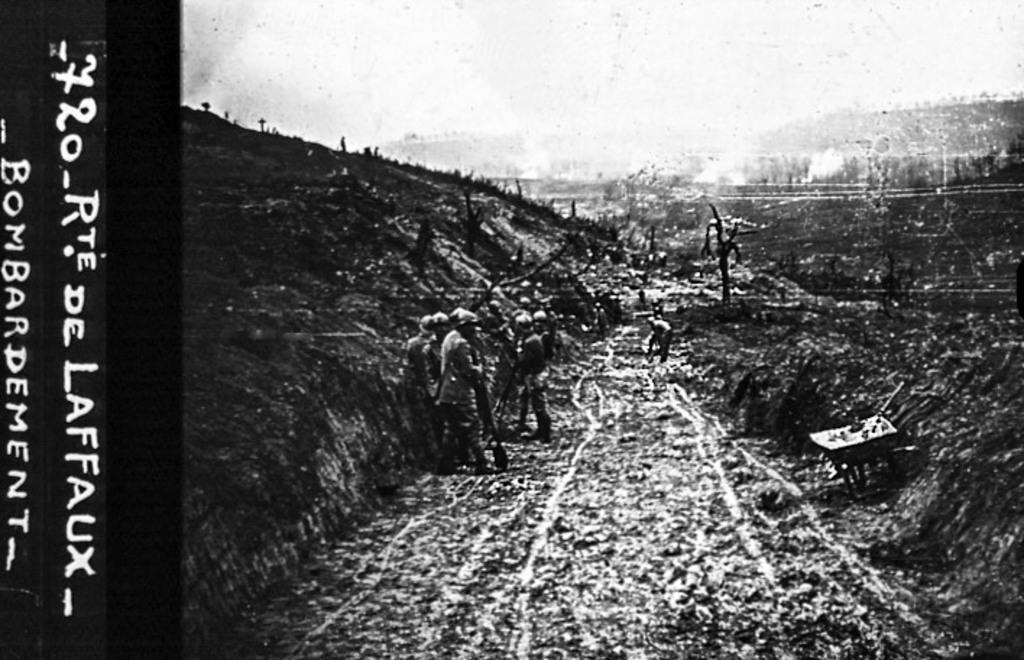<image>
Offer a succinct explanation of the picture presented. The black and white historical photo was annotated, "720 Rte de Laffaux Bombardement" 